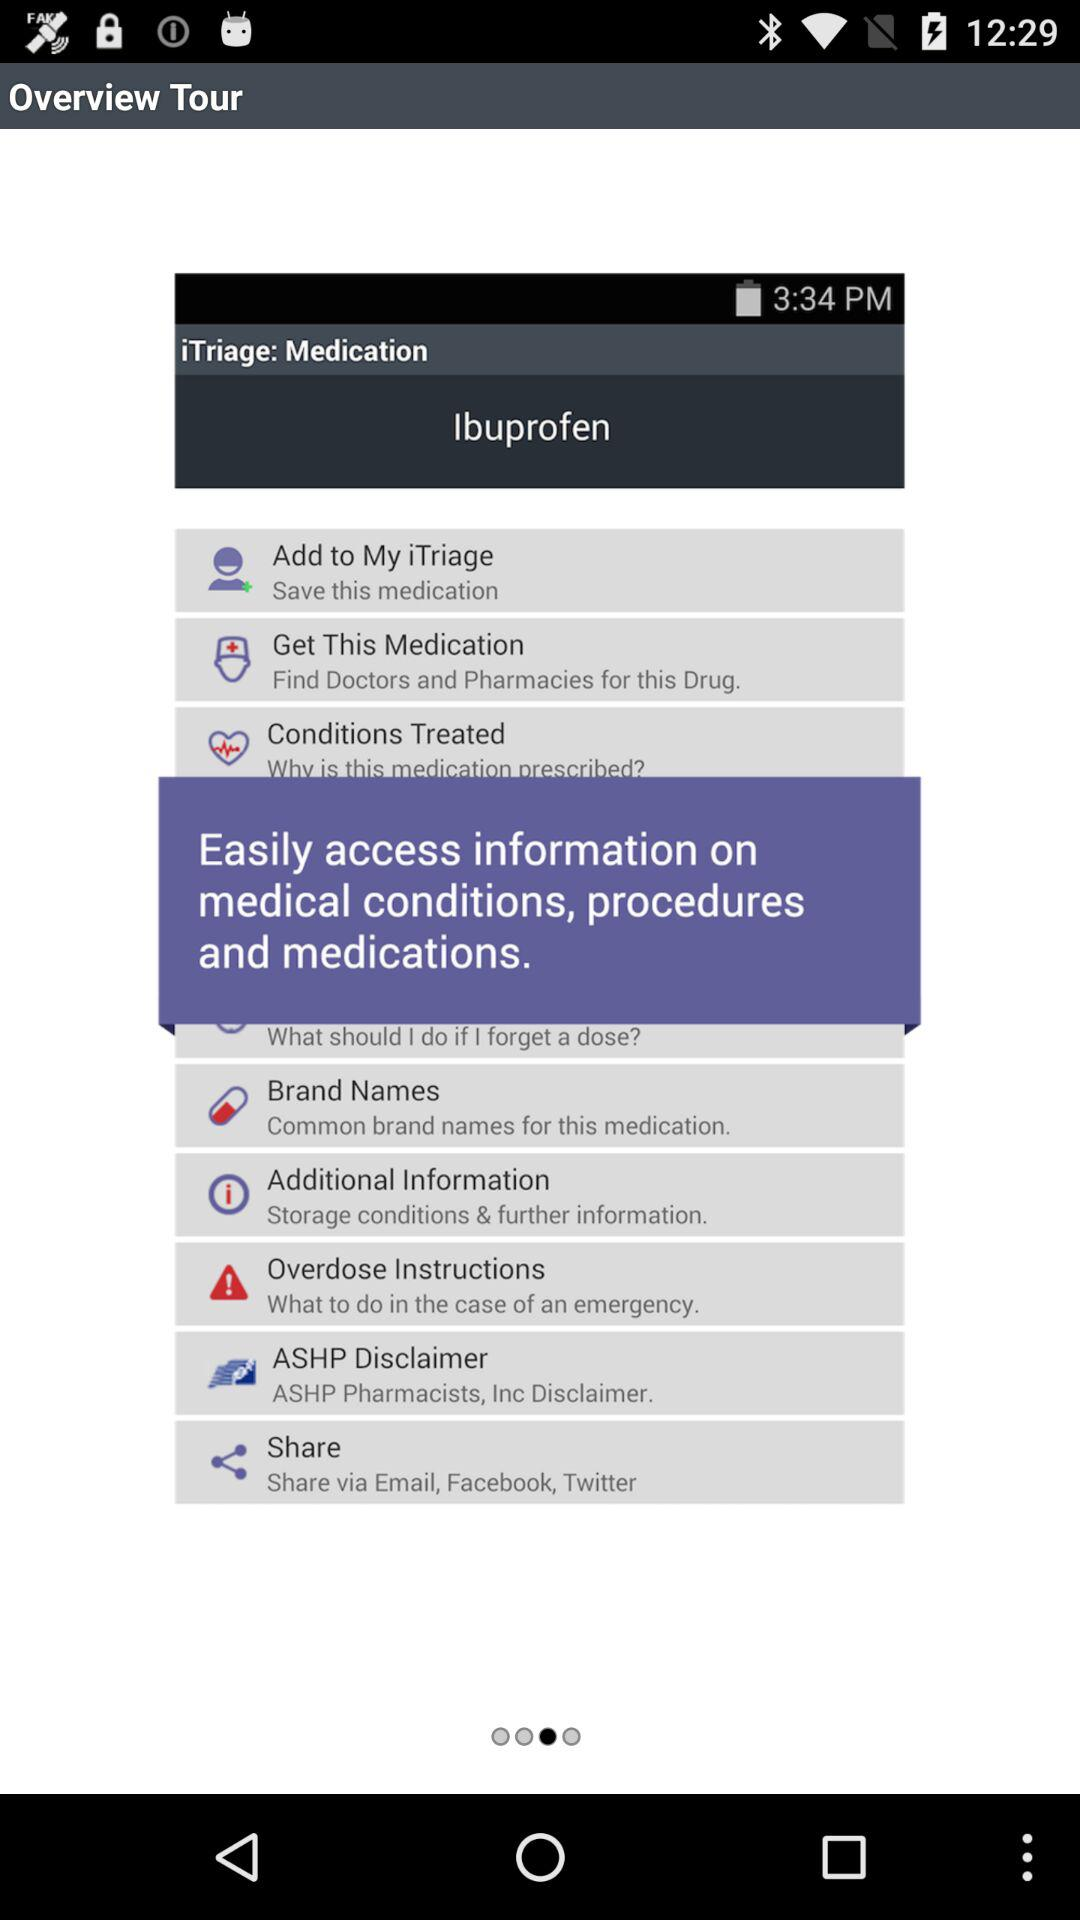What options are available to share the information? The available options are "Email", "Facebook" and "Twitter". 